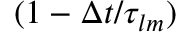<formula> <loc_0><loc_0><loc_500><loc_500>( 1 - \Delta t / \tau _ { l m } )</formula> 